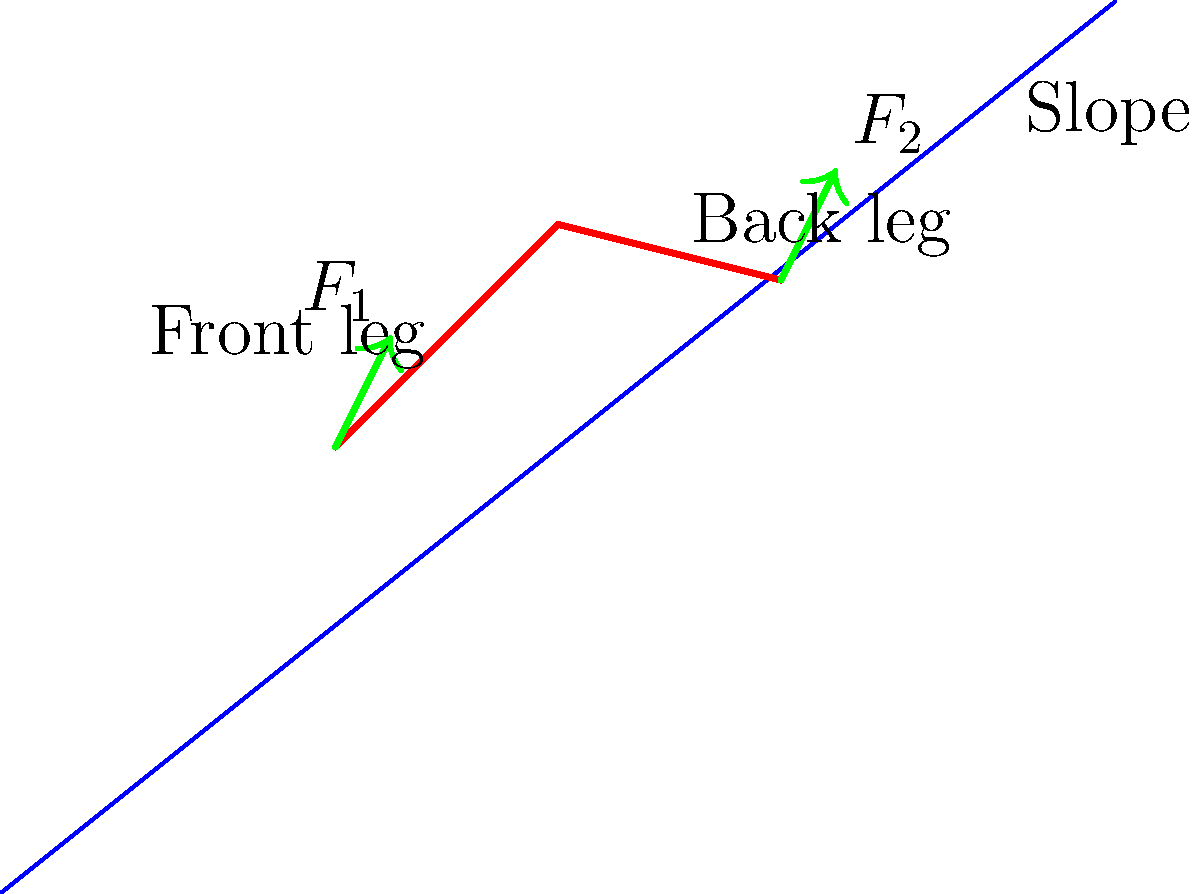During a telemark turn on a snowy slope, a skier's weight is distributed unevenly between the front and back leg. If the total force on both legs is 800 N and the force on the front leg ($F_1$) is 60% of the force on the back leg ($F_2$), calculate the magnitude of the force on each leg. Let's approach this step-by-step:

1) Let $F_1$ be the force on the front leg and $F_2$ be the force on the back leg.

2) We're given that the total force is 800 N, so:
   $$F_1 + F_2 = 800 \text{ N}$$

3) We're also told that $F_1$ is 60% of $F_2$. This can be expressed as:
   $$F_1 = 0.6F_2$$

4) Substituting this into our first equation:
   $$0.6F_2 + F_2 = 800 \text{ N}$$
   $$1.6F_2 = 800 \text{ N}$$

5) Solving for $F_2$:
   $$F_2 = 800 \text{ N} \div 1.6 = 500 \text{ N}$$

6) Now that we know $F_2$, we can calculate $F_1$:
   $$F_1 = 0.6F_2 = 0.6 \times 500 \text{ N} = 300 \text{ N}$$

7) Let's verify:
   $$F_1 + F_2 = 300 \text{ N} + 500 \text{ N} = 800 \text{ N}$$

Thus, the force on the front leg ($F_1$) is 300 N, and the force on the back leg ($F_2$) is 500 N.
Answer: Front leg: 300 N, Back leg: 500 N 